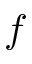Convert formula to latex. <formula><loc_0><loc_0><loc_500><loc_500>f</formula> 